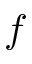Convert formula to latex. <formula><loc_0><loc_0><loc_500><loc_500>f</formula> 